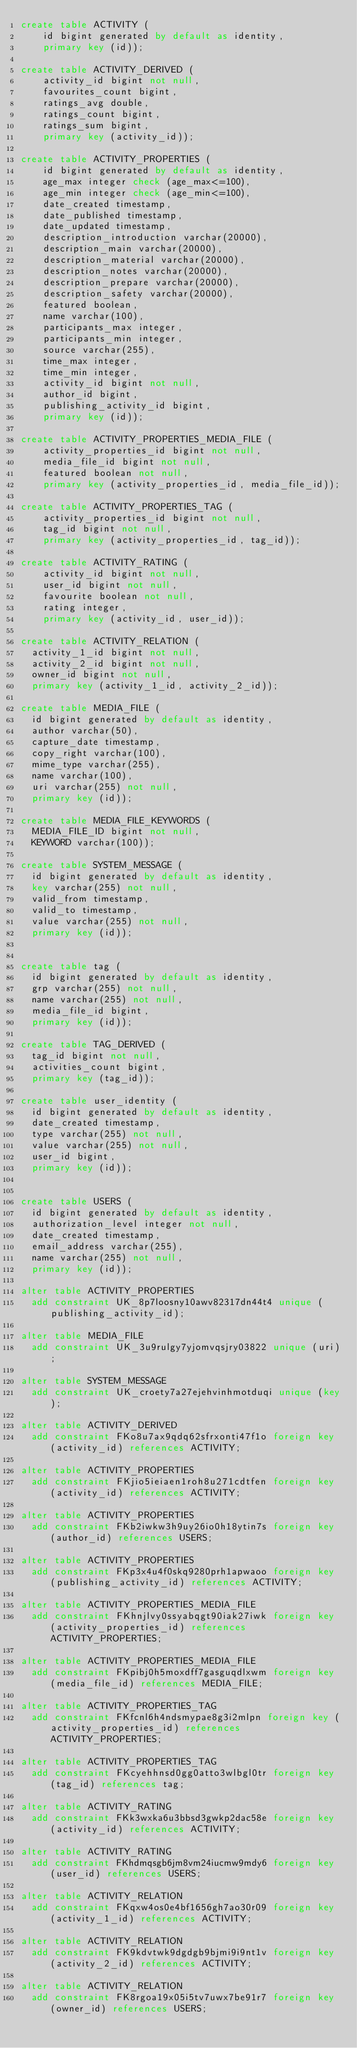<code> <loc_0><loc_0><loc_500><loc_500><_SQL_>create table ACTIVITY (
	id bigint generated by default as identity,
	primary key (id));

create table ACTIVITY_DERIVED (
	activity_id bigint not null,
	favourites_count bigint,
	ratings_avg double,
	ratings_count bigint,
	ratings_sum bigint,
	primary key (activity_id));

create table ACTIVITY_PROPERTIES (
	id bigint generated by default as identity,
	age_max integer check (age_max<=100),
	age_min integer check (age_min<=100),
	date_created timestamp,
	date_published timestamp,
	date_updated timestamp,
	description_introduction varchar(20000),
	description_main varchar(20000),
	description_material varchar(20000),
	description_notes varchar(20000),
	description_prepare varchar(20000),
	description_safety varchar(20000),
	featured boolean,
	name varchar(100),
	participants_max integer,
	participants_min integer,
	source varchar(255),
	time_max integer,
	time_min integer,
	activity_id bigint not null,
	author_id bigint,
	publishing_activity_id bigint,
	primary key (id));

create table ACTIVITY_PROPERTIES_MEDIA_FILE (
	activity_properties_id bigint not null,
	media_file_id bigint not null,
	featured boolean not null,
	primary key (activity_properties_id, media_file_id));

create table ACTIVITY_PROPERTIES_TAG (
	activity_properties_id bigint not null,
	tag_id bigint not null,
	primary key (activity_properties_id, tag_id));

create table ACTIVITY_RATING (
	activity_id bigint not null,
	user_id bigint not null,
	favourite boolean not null,
	rating integer,
	primary key (activity_id, user_id));

create table ACTIVITY_RELATION (
  activity_1_id bigint not null,
  activity_2_id bigint not null,
  owner_id bigint not null,
  primary key (activity_1_id, activity_2_id));

create table MEDIA_FILE (
  id bigint generated by default as identity,
  author varchar(50),
  capture_date timestamp,
  copy_right varchar(100),
  mime_type varchar(255),
  name varchar(100),
  uri varchar(255) not null,
  primary key (id));

create table MEDIA_FILE_KEYWORDS (
  MEDIA_FILE_ID bigint not null,
  KEYWORD varchar(100));

create table SYSTEM_MESSAGE (
  id bigint generated by default as identity,
  key varchar(255) not null,
  valid_from timestamp,
  valid_to timestamp,
  value varchar(255) not null,
  primary key (id));


create table tag (
  id bigint generated by default as identity,
  grp varchar(255) not null,
  name varchar(255) not null,
  media_file_id bigint,
  primary key (id));

create table TAG_DERIVED (
  tag_id bigint not null,
  activities_count bigint,
  primary key (tag_id));

create table user_identity (
  id bigint generated by default as identity,
  date_created timestamp,
  type varchar(255) not null,
  value varchar(255) not null,
  user_id bigint,
  primary key (id));


create table USERS (
  id bigint generated by default as identity,
  authorization_level integer not null,
  date_created timestamp,
  email_address varchar(255),
  name varchar(255) not null,
  primary key (id));

alter table ACTIVITY_PROPERTIES
  add constraint UK_8p7loosny10awv82317dn44t4 unique (publishing_activity_id);

alter table MEDIA_FILE
  add constraint UK_3u9rulgy7yjomvqsjry03822 unique (uri);

alter table SYSTEM_MESSAGE
  add constraint UK_croety7a27ejehvinhmotduqi unique (key);

alter table ACTIVITY_DERIVED
  add constraint FKo8u7ax9qdq62sfrxonti47f1o foreign key (activity_id) references ACTIVITY;

alter table ACTIVITY_PROPERTIES
  add constraint FKjio5ieiaen1roh8u271cdtfen foreign key (activity_id) references ACTIVITY;

alter table ACTIVITY_PROPERTIES
  add constraint FKb2iwkw3h9uy26io0h18ytin7s foreign key (author_id) references USERS;

alter table ACTIVITY_PROPERTIES
  add constraint FKp3x4u4f0skq9280prh1apwaoo foreign key (publishing_activity_id) references ACTIVITY;

alter table ACTIVITY_PROPERTIES_MEDIA_FILE
  add constraint FKhnjlvy0ssyabqgt90iak27iwk foreign key (activity_properties_id) references ACTIVITY_PROPERTIES;

alter table ACTIVITY_PROPERTIES_MEDIA_FILE
  add constraint FKpibj0h5moxdff7gasguqdlxwm foreign key (media_file_id) references MEDIA_FILE;

alter table ACTIVITY_PROPERTIES_TAG
  add constraint FKfcnl6h4ndsmypae8g3i2mlpn foreign key (activity_properties_id) references ACTIVITY_PROPERTIES;

alter table ACTIVITY_PROPERTIES_TAG
  add constraint FKcyehhnsd0gg0atto3wlbgl0tr foreign key (tag_id) references tag;

alter table ACTIVITY_RATING
  add constraint FKk3wxka6u3bbsd3gwkp2dac58e foreign key (activity_id) references ACTIVITY;

alter table ACTIVITY_RATING
  add constraint FKhdmqsgb6jm8vm24iucmw9mdy6 foreign key (user_id) references USERS;

alter table ACTIVITY_RELATION
  add constraint FKqxw4os0e4bf1656gh7ao30r09 foreign key (activity_1_id) references ACTIVITY;

alter table ACTIVITY_RELATION
  add constraint FK9kdvtwk9dgdgb9bjmi9i9nt1v foreign key (activity_2_id) references ACTIVITY;

alter table ACTIVITY_RELATION
  add constraint FK8rgoa19x05i5tv7uwx7be91r7 foreign key (owner_id) references USERS;
</code> 